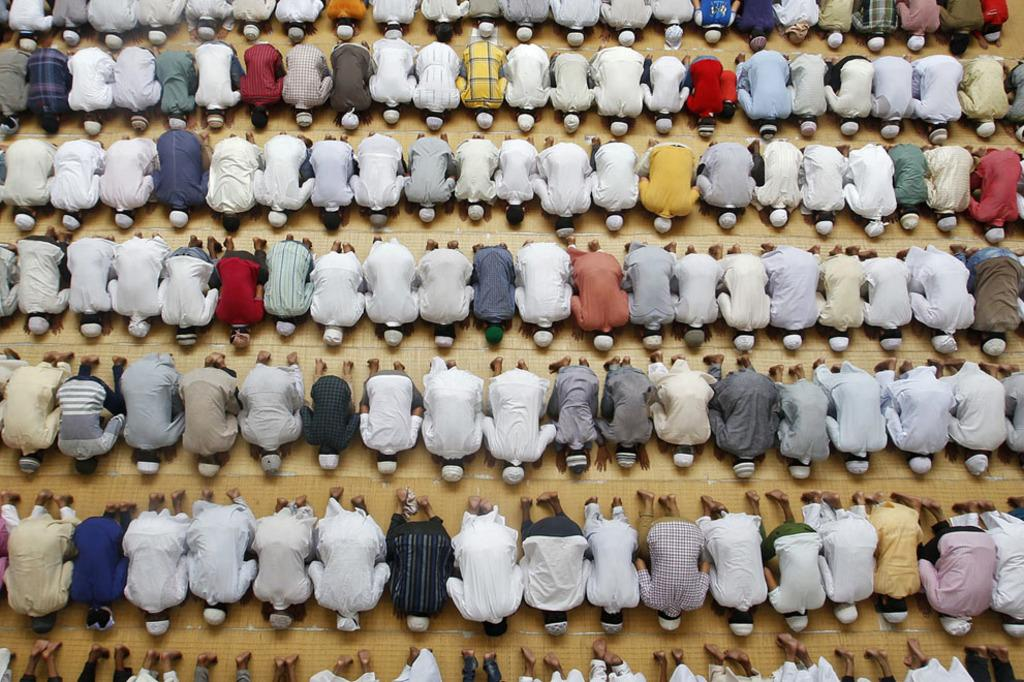How many people are in the image? There is a group of people in the image, but the exact number is not specified. What are the people doing in the image? The people are on the ground, but their specific activity is not mentioned. What type of flower is being used as a territory marker by the people in the image? There is no flower or territory marker present in the image; it only shows a group of people on the ground. 